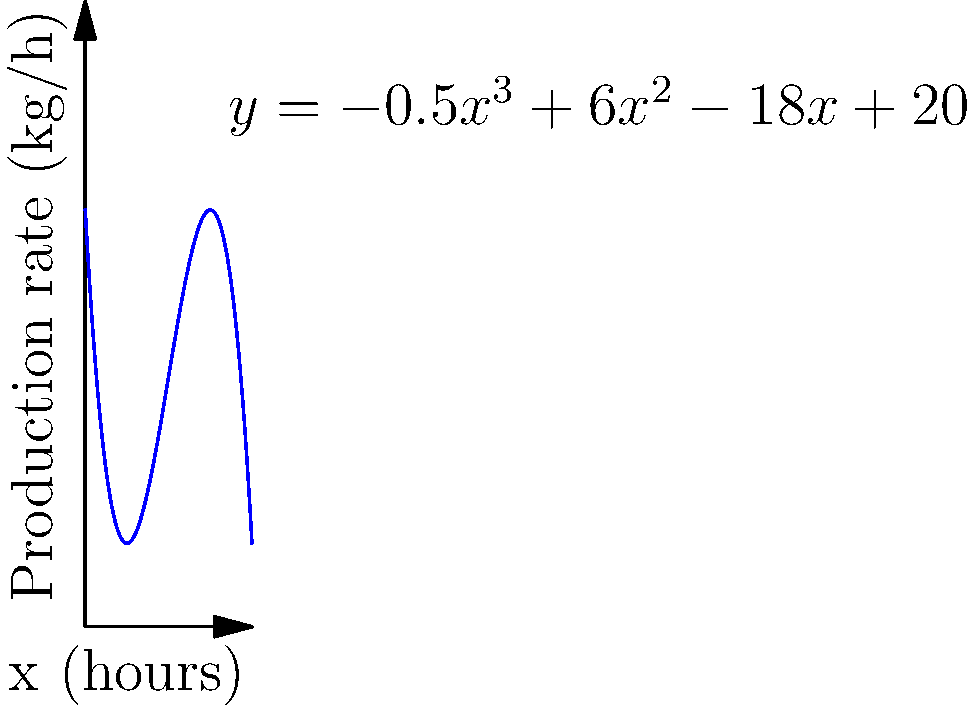Your eco-friendly polymer production rate (in kg/h) over time (in hours) is modeled by the cubic function $y=-0.5x^3+6x^2-18x+20$, where $x$ represents the number of hours since production started and $y$ represents the production rate. At what hour does the production rate reach its maximum value, and what is this maximum rate? To find the maximum production rate, we need to follow these steps:

1) The maximum point occurs where the derivative of the function is zero. Let's find the derivative:
   $\frac{dy}{dx} = -1.5x^2 + 12x - 18$

2) Set the derivative equal to zero and solve for x:
   $-1.5x^2 + 12x - 18 = 0$

3) This is a quadratic equation. We can solve it using the quadratic formula:
   $x = \frac{-b \pm \sqrt{b^2 - 4ac}}{2a}$

   Where $a=-1.5$, $b=12$, and $c=-18$

4) Plugging in these values:
   $x = \frac{-12 \pm \sqrt{144 - 4(-1.5)(-18)}}{2(-1.5)}$
   $= \frac{-12 \pm \sqrt{144 - 108}}{-3}$
   $= \frac{-12 \pm 6}{-3}$

5) This gives us two solutions:
   $x_1 = \frac{-12 + 6}{-3} = 2$
   $x_2 = \frac{-12 - 6}{-3} = 6$

6) To determine which of these gives the maximum (rather than minimum) value, we can check the second derivative:
   $\frac{d^2y}{dx^2} = -3x + 12$

   At $x=2$: $-3(2) + 12 = 6$ (positive, so this is a minimum)
   At $x=6$: $-3(6) + 12 = -6$ (negative, so this is a maximum)

7) Therefore, the maximum occurs at $x=6$ hours.

8) To find the maximum production rate, we plug $x=6$ into the original function:
   $y = -0.5(6)^3 + 6(6)^2 - 18(6) + 20$
   $= -108 + 216 - 108 + 20$
   $= 20$ kg/h

Thus, the maximum production rate of 20 kg/h occurs 6 hours after production starts.
Answer: 6 hours; 20 kg/h 